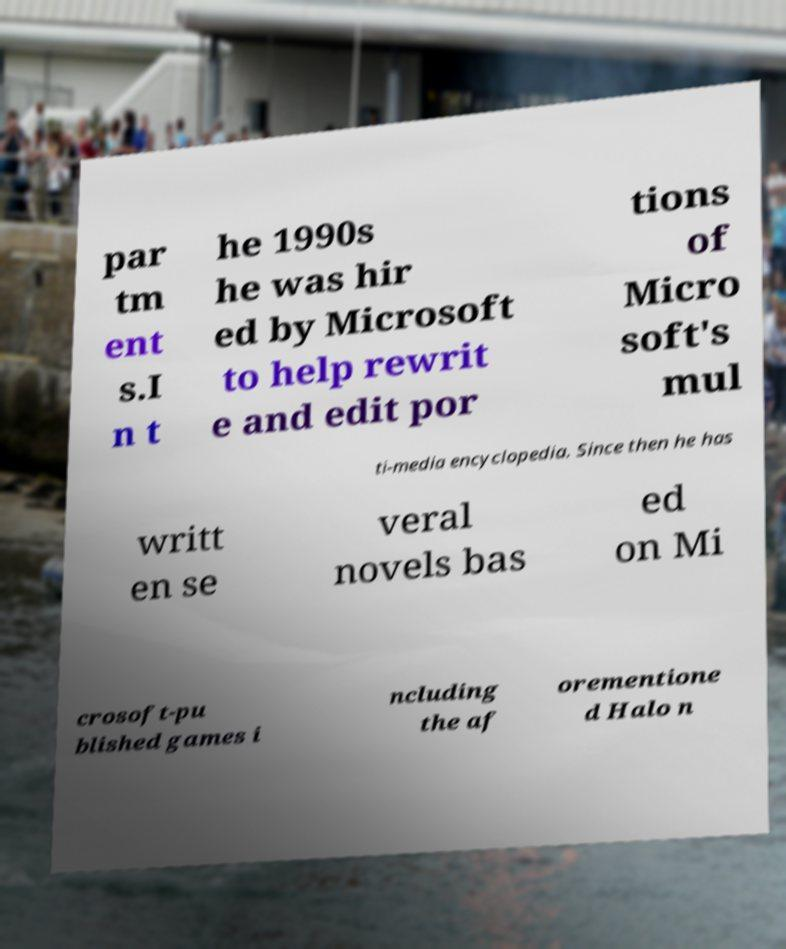What messages or text are displayed in this image? I need them in a readable, typed format. par tm ent s.I n t he 1990s he was hir ed by Microsoft to help rewrit e and edit por tions of Micro soft's mul ti-media encyclopedia. Since then he has writt en se veral novels bas ed on Mi crosoft-pu blished games i ncluding the af orementione d Halo n 